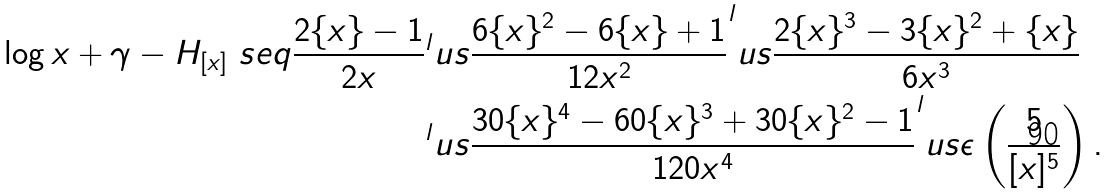Convert formula to latex. <formula><loc_0><loc_0><loc_500><loc_500>\log x + \gamma - H _ { [ x ] } \ s e q \frac { 2 \{ x \} - 1 } { 2 x } & ^ { l } u s \frac { 6 \{ x \} ^ { 2 } - 6 \{ x \} + 1 } { 1 2 x ^ { 2 } } ^ { l } u s \frac { 2 \{ x \} ^ { 3 } - 3 \{ x \} ^ { 2 } + \{ x \} } { 6 x ^ { 3 } } \\ & ^ { l } u s \frac { 3 0 \{ x \} ^ { 4 } - 6 0 \{ x \} ^ { 3 } + 3 0 \{ x \} ^ { 2 } - 1 } { 1 2 0 x ^ { 4 } } ^ { l } u s \epsilon \left ( \frac { 5 } { [ x ] ^ { 5 } } \right ) .</formula> 